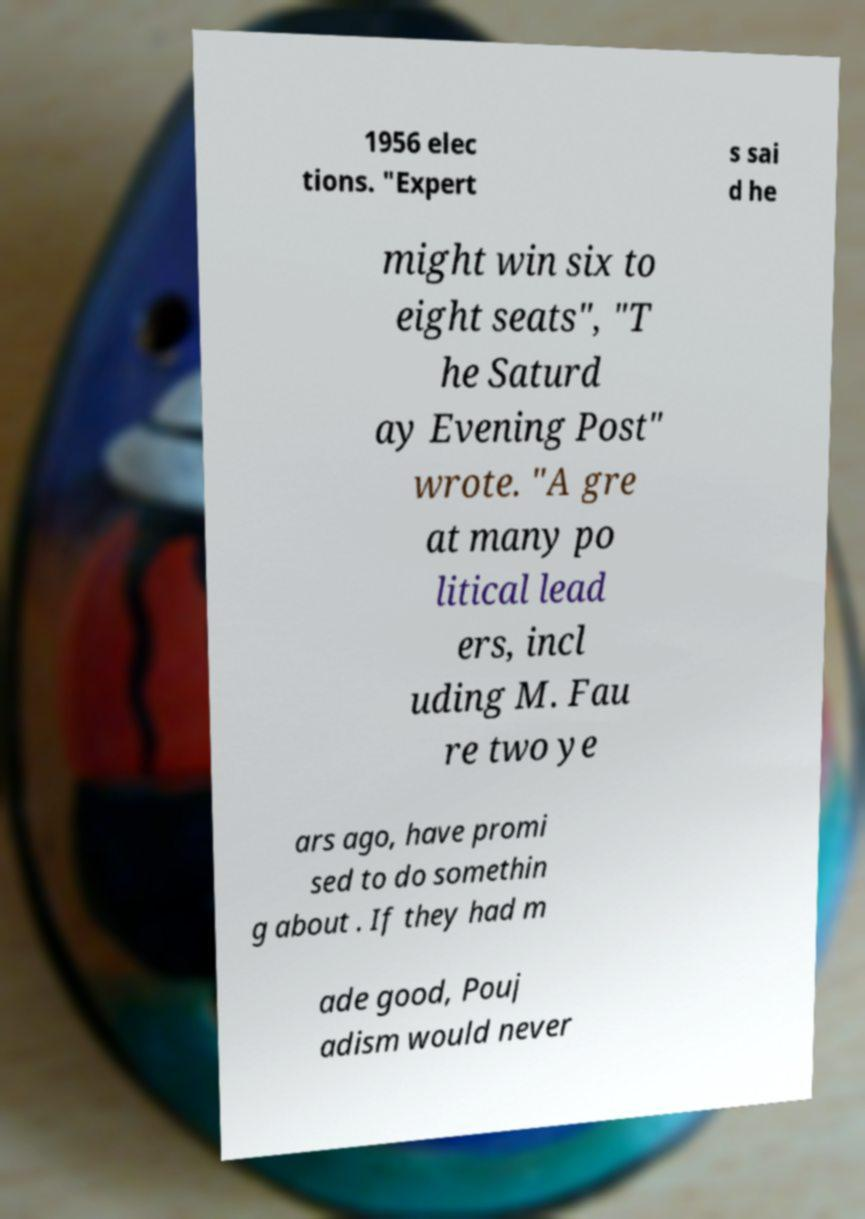Please read and relay the text visible in this image. What does it say? 1956 elec tions. "Expert s sai d he might win six to eight seats", "T he Saturd ay Evening Post" wrote. "A gre at many po litical lead ers, incl uding M. Fau re two ye ars ago, have promi sed to do somethin g about . If they had m ade good, Pouj adism would never 